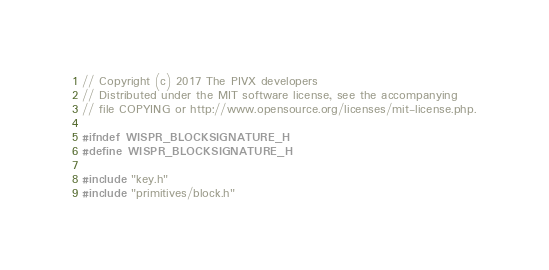Convert code to text. <code><loc_0><loc_0><loc_500><loc_500><_C_>// Copyright (c) 2017 The PIVX developers
// Distributed under the MIT software license, see the accompanying
// file COPYING or http://www.opensource.org/licenses/mit-license.php.

#ifndef WISPR_BLOCKSIGNATURE_H
#define WISPR_BLOCKSIGNATURE_H

#include "key.h"
#include "primitives/block.h"</code> 